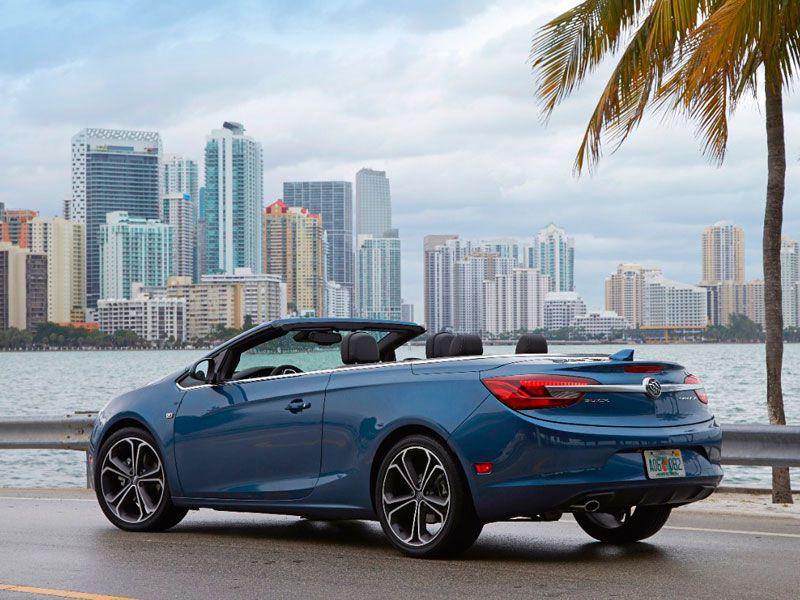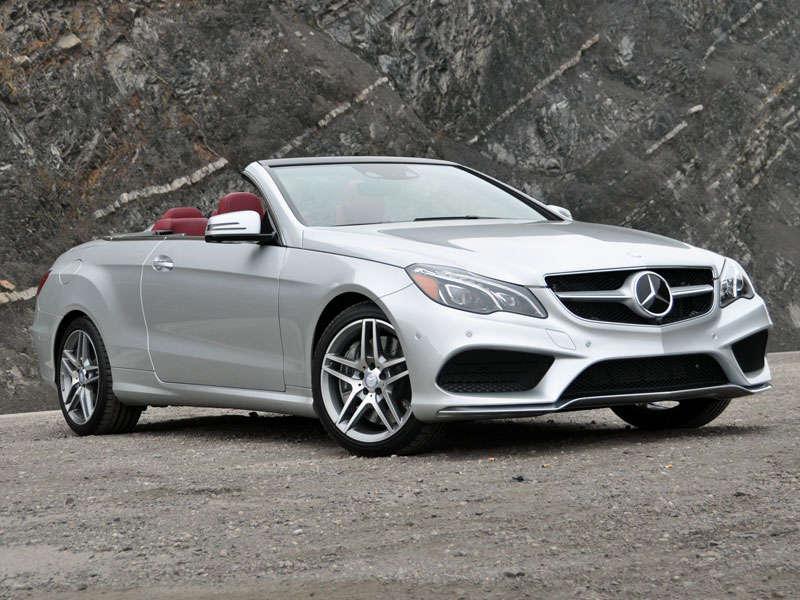The first image is the image on the left, the second image is the image on the right. Assess this claim about the two images: "An image shows a bright blue convertible with its top down.". Correct or not? Answer yes or no. Yes. The first image is the image on the left, the second image is the image on the right. For the images shown, is this caption "There is a blue car in the left image." true? Answer yes or no. Yes. 